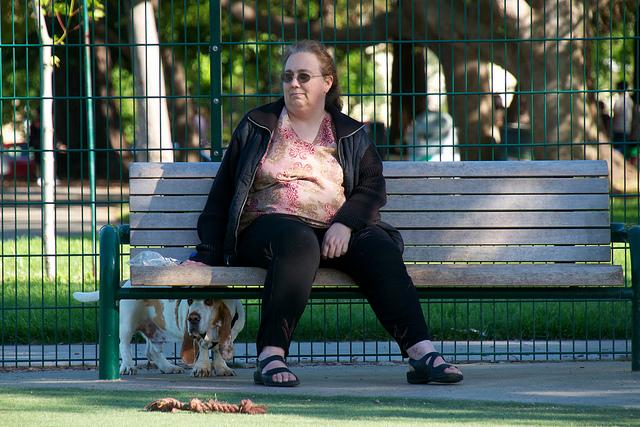What dog breed does the woman have?

Choices:
A) pug
B) bassett hound
C) dachshund
D) shiba inu bassett hound 